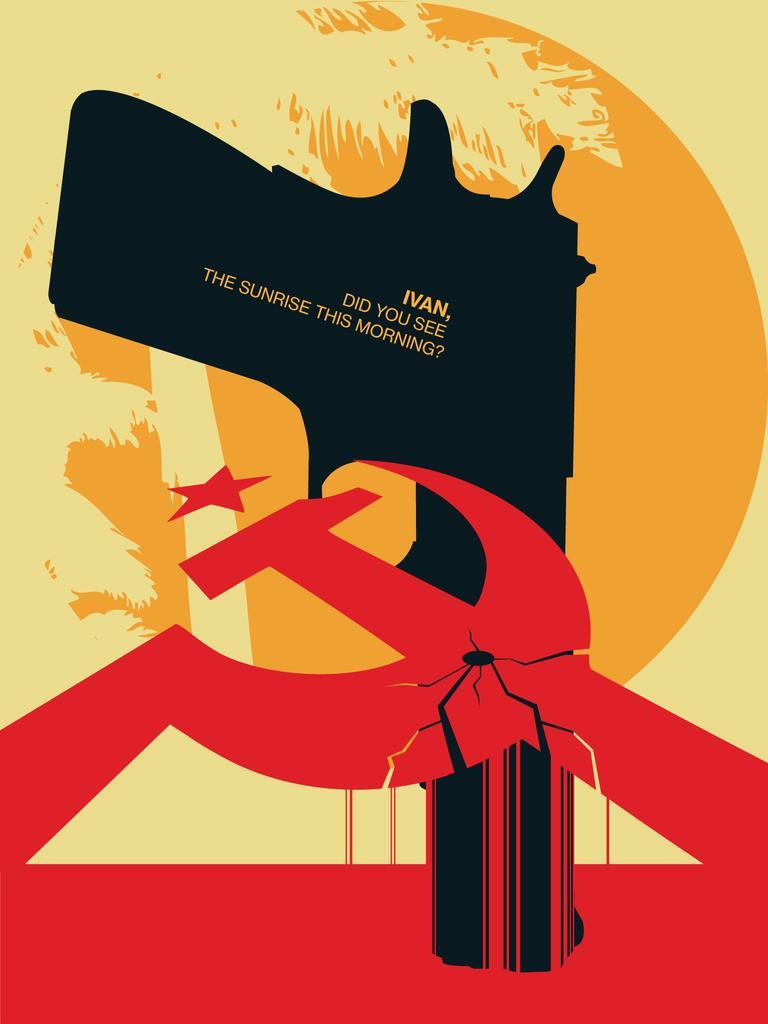Please provide a concise description of this image. This image consists of a poster in which there is a gun in black color. And we can also see a text. 